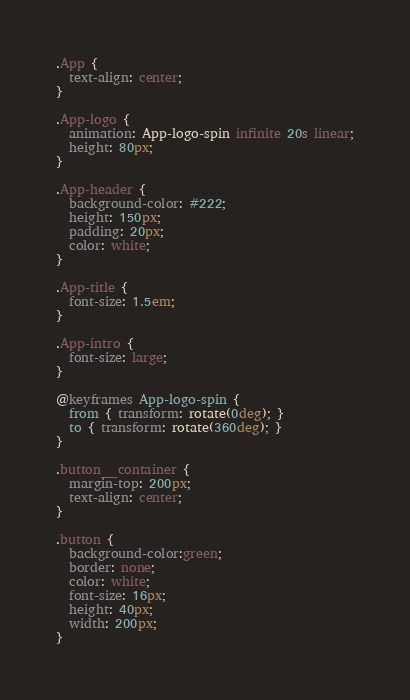<code> <loc_0><loc_0><loc_500><loc_500><_CSS_>.App {
  text-align: center;
}

.App-logo {
  animation: App-logo-spin infinite 20s linear;
  height: 80px;
}

.App-header {
  background-color: #222;
  height: 150px;
  padding: 20px;
  color: white;
}

.App-title {
  font-size: 1.5em;
}

.App-intro {
  font-size: large;
}

@keyframes App-logo-spin {
  from { transform: rotate(0deg); }
  to { transform: rotate(360deg); }
}

.button__container {
  margin-top: 200px;
  text-align: center;
}

.button {
  background-color:green;
  border: none;
  color: white;
  font-size: 16px;
  height: 40px;
  width: 200px;
}
</code> 